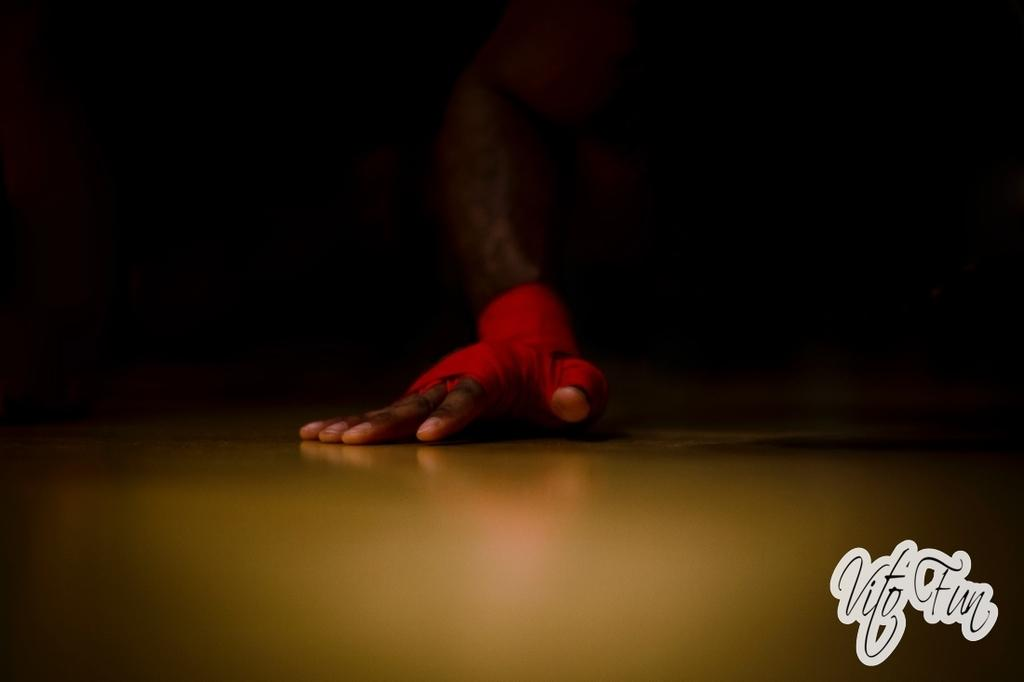What part of a person is visible in the image? There is a hand of a person in the image. Where is the hand located in the image? The hand is on a surface. What type of camera is being used to capture the story in the image? There is no camera or story present in the image; it only shows a hand on a surface. 